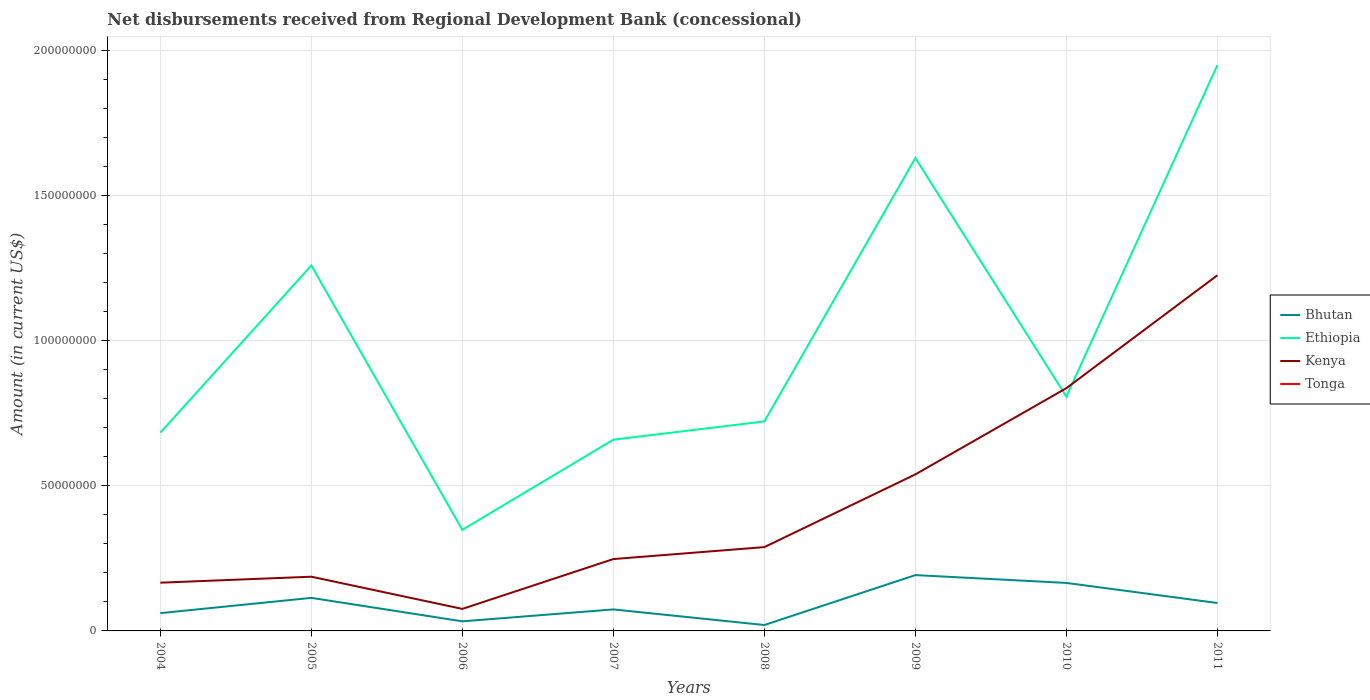Does the line corresponding to Kenya intersect with the line corresponding to Bhutan?
Your answer should be compact. No. Across all years, what is the maximum amount of disbursements received from Regional Development Bank in Ethiopia?
Ensure brevity in your answer.  3.48e+07. What is the total amount of disbursements received from Regional Development Bank in Bhutan in the graph?
Provide a succinct answer. -9.14e+06. What is the difference between the highest and the second highest amount of disbursements received from Regional Development Bank in Ethiopia?
Provide a short and direct response. 1.60e+08. What is the difference between the highest and the lowest amount of disbursements received from Regional Development Bank in Tonga?
Your answer should be compact. 0. How many lines are there?
Make the answer very short. 3. How many years are there in the graph?
Offer a terse response. 8. What is the difference between two consecutive major ticks on the Y-axis?
Ensure brevity in your answer.  5.00e+07. Are the values on the major ticks of Y-axis written in scientific E-notation?
Provide a succinct answer. No. Does the graph contain any zero values?
Provide a succinct answer. Yes. Where does the legend appear in the graph?
Offer a terse response. Center right. What is the title of the graph?
Offer a very short reply. Net disbursements received from Regional Development Bank (concessional). Does "Lesotho" appear as one of the legend labels in the graph?
Your answer should be compact. No. What is the Amount (in current US$) of Bhutan in 2004?
Provide a short and direct response. 6.13e+06. What is the Amount (in current US$) of Ethiopia in 2004?
Ensure brevity in your answer.  6.83e+07. What is the Amount (in current US$) of Kenya in 2004?
Give a very brief answer. 1.66e+07. What is the Amount (in current US$) of Bhutan in 2005?
Provide a succinct answer. 1.14e+07. What is the Amount (in current US$) in Ethiopia in 2005?
Offer a very short reply. 1.26e+08. What is the Amount (in current US$) in Kenya in 2005?
Ensure brevity in your answer.  1.87e+07. What is the Amount (in current US$) in Tonga in 2005?
Make the answer very short. 0. What is the Amount (in current US$) of Bhutan in 2006?
Keep it short and to the point. 3.30e+06. What is the Amount (in current US$) of Ethiopia in 2006?
Provide a short and direct response. 3.48e+07. What is the Amount (in current US$) in Kenya in 2006?
Offer a very short reply. 7.59e+06. What is the Amount (in current US$) of Bhutan in 2007?
Your answer should be compact. 7.41e+06. What is the Amount (in current US$) of Ethiopia in 2007?
Ensure brevity in your answer.  6.59e+07. What is the Amount (in current US$) of Kenya in 2007?
Offer a terse response. 2.48e+07. What is the Amount (in current US$) of Bhutan in 2008?
Offer a very short reply. 2.03e+06. What is the Amount (in current US$) of Ethiopia in 2008?
Keep it short and to the point. 7.22e+07. What is the Amount (in current US$) in Kenya in 2008?
Offer a very short reply. 2.89e+07. What is the Amount (in current US$) in Bhutan in 2009?
Your response must be concise. 1.92e+07. What is the Amount (in current US$) of Ethiopia in 2009?
Offer a very short reply. 1.63e+08. What is the Amount (in current US$) of Kenya in 2009?
Your answer should be very brief. 5.40e+07. What is the Amount (in current US$) in Tonga in 2009?
Offer a terse response. 0. What is the Amount (in current US$) in Bhutan in 2010?
Your answer should be very brief. 1.65e+07. What is the Amount (in current US$) in Ethiopia in 2010?
Offer a very short reply. 8.08e+07. What is the Amount (in current US$) of Kenya in 2010?
Offer a terse response. 8.37e+07. What is the Amount (in current US$) of Bhutan in 2011?
Provide a short and direct response. 9.62e+06. What is the Amount (in current US$) of Ethiopia in 2011?
Your answer should be very brief. 1.95e+08. What is the Amount (in current US$) in Kenya in 2011?
Keep it short and to the point. 1.23e+08. Across all years, what is the maximum Amount (in current US$) in Bhutan?
Provide a short and direct response. 1.92e+07. Across all years, what is the maximum Amount (in current US$) of Ethiopia?
Offer a very short reply. 1.95e+08. Across all years, what is the maximum Amount (in current US$) in Kenya?
Offer a terse response. 1.23e+08. Across all years, what is the minimum Amount (in current US$) in Bhutan?
Your answer should be compact. 2.03e+06. Across all years, what is the minimum Amount (in current US$) of Ethiopia?
Provide a succinct answer. 3.48e+07. Across all years, what is the minimum Amount (in current US$) in Kenya?
Provide a short and direct response. 7.59e+06. What is the total Amount (in current US$) of Bhutan in the graph?
Keep it short and to the point. 7.57e+07. What is the total Amount (in current US$) of Ethiopia in the graph?
Offer a very short reply. 8.06e+08. What is the total Amount (in current US$) in Kenya in the graph?
Keep it short and to the point. 3.57e+08. What is the difference between the Amount (in current US$) in Bhutan in 2004 and that in 2005?
Make the answer very short. -5.26e+06. What is the difference between the Amount (in current US$) in Ethiopia in 2004 and that in 2005?
Your response must be concise. -5.76e+07. What is the difference between the Amount (in current US$) of Kenya in 2004 and that in 2005?
Ensure brevity in your answer.  -2.06e+06. What is the difference between the Amount (in current US$) of Bhutan in 2004 and that in 2006?
Your response must be concise. 2.83e+06. What is the difference between the Amount (in current US$) of Ethiopia in 2004 and that in 2006?
Provide a short and direct response. 3.35e+07. What is the difference between the Amount (in current US$) of Kenya in 2004 and that in 2006?
Give a very brief answer. 9.04e+06. What is the difference between the Amount (in current US$) in Bhutan in 2004 and that in 2007?
Offer a terse response. -1.28e+06. What is the difference between the Amount (in current US$) in Ethiopia in 2004 and that in 2007?
Offer a terse response. 2.41e+06. What is the difference between the Amount (in current US$) in Kenya in 2004 and that in 2007?
Ensure brevity in your answer.  -8.14e+06. What is the difference between the Amount (in current US$) of Bhutan in 2004 and that in 2008?
Your response must be concise. 4.10e+06. What is the difference between the Amount (in current US$) in Ethiopia in 2004 and that in 2008?
Your answer should be very brief. -3.87e+06. What is the difference between the Amount (in current US$) in Kenya in 2004 and that in 2008?
Your answer should be compact. -1.23e+07. What is the difference between the Amount (in current US$) in Bhutan in 2004 and that in 2009?
Your response must be concise. -1.31e+07. What is the difference between the Amount (in current US$) in Ethiopia in 2004 and that in 2009?
Keep it short and to the point. -9.47e+07. What is the difference between the Amount (in current US$) of Kenya in 2004 and that in 2009?
Offer a very short reply. -3.73e+07. What is the difference between the Amount (in current US$) in Bhutan in 2004 and that in 2010?
Provide a short and direct response. -1.04e+07. What is the difference between the Amount (in current US$) of Ethiopia in 2004 and that in 2010?
Make the answer very short. -1.24e+07. What is the difference between the Amount (in current US$) of Kenya in 2004 and that in 2010?
Your answer should be very brief. -6.70e+07. What is the difference between the Amount (in current US$) in Bhutan in 2004 and that in 2011?
Give a very brief answer. -3.49e+06. What is the difference between the Amount (in current US$) in Ethiopia in 2004 and that in 2011?
Offer a very short reply. -1.27e+08. What is the difference between the Amount (in current US$) of Kenya in 2004 and that in 2011?
Provide a short and direct response. -1.06e+08. What is the difference between the Amount (in current US$) in Bhutan in 2005 and that in 2006?
Provide a short and direct response. 8.09e+06. What is the difference between the Amount (in current US$) in Ethiopia in 2005 and that in 2006?
Offer a very short reply. 9.11e+07. What is the difference between the Amount (in current US$) of Kenya in 2005 and that in 2006?
Make the answer very short. 1.11e+07. What is the difference between the Amount (in current US$) of Bhutan in 2005 and that in 2007?
Ensure brevity in your answer.  3.98e+06. What is the difference between the Amount (in current US$) of Ethiopia in 2005 and that in 2007?
Keep it short and to the point. 6.00e+07. What is the difference between the Amount (in current US$) in Kenya in 2005 and that in 2007?
Give a very brief answer. -6.08e+06. What is the difference between the Amount (in current US$) in Bhutan in 2005 and that in 2008?
Give a very brief answer. 9.36e+06. What is the difference between the Amount (in current US$) in Ethiopia in 2005 and that in 2008?
Make the answer very short. 5.37e+07. What is the difference between the Amount (in current US$) in Kenya in 2005 and that in 2008?
Offer a very short reply. -1.02e+07. What is the difference between the Amount (in current US$) of Bhutan in 2005 and that in 2009?
Provide a short and direct response. -7.85e+06. What is the difference between the Amount (in current US$) of Ethiopia in 2005 and that in 2009?
Provide a short and direct response. -3.70e+07. What is the difference between the Amount (in current US$) in Kenya in 2005 and that in 2009?
Offer a very short reply. -3.53e+07. What is the difference between the Amount (in current US$) in Bhutan in 2005 and that in 2010?
Your answer should be compact. -5.15e+06. What is the difference between the Amount (in current US$) of Ethiopia in 2005 and that in 2010?
Your answer should be compact. 4.52e+07. What is the difference between the Amount (in current US$) of Kenya in 2005 and that in 2010?
Offer a terse response. -6.50e+07. What is the difference between the Amount (in current US$) of Bhutan in 2005 and that in 2011?
Your response must be concise. 1.77e+06. What is the difference between the Amount (in current US$) in Ethiopia in 2005 and that in 2011?
Your response must be concise. -6.90e+07. What is the difference between the Amount (in current US$) in Kenya in 2005 and that in 2011?
Offer a terse response. -1.04e+08. What is the difference between the Amount (in current US$) in Bhutan in 2006 and that in 2007?
Make the answer very short. -4.10e+06. What is the difference between the Amount (in current US$) of Ethiopia in 2006 and that in 2007?
Your answer should be compact. -3.11e+07. What is the difference between the Amount (in current US$) of Kenya in 2006 and that in 2007?
Provide a short and direct response. -1.72e+07. What is the difference between the Amount (in current US$) of Bhutan in 2006 and that in 2008?
Offer a very short reply. 1.27e+06. What is the difference between the Amount (in current US$) in Ethiopia in 2006 and that in 2008?
Make the answer very short. -3.74e+07. What is the difference between the Amount (in current US$) in Kenya in 2006 and that in 2008?
Offer a terse response. -2.13e+07. What is the difference between the Amount (in current US$) of Bhutan in 2006 and that in 2009?
Make the answer very short. -1.59e+07. What is the difference between the Amount (in current US$) of Ethiopia in 2006 and that in 2009?
Your response must be concise. -1.28e+08. What is the difference between the Amount (in current US$) of Kenya in 2006 and that in 2009?
Provide a succinct answer. -4.64e+07. What is the difference between the Amount (in current US$) in Bhutan in 2006 and that in 2010?
Give a very brief answer. -1.32e+07. What is the difference between the Amount (in current US$) in Ethiopia in 2006 and that in 2010?
Offer a very short reply. -4.59e+07. What is the difference between the Amount (in current US$) in Kenya in 2006 and that in 2010?
Give a very brief answer. -7.61e+07. What is the difference between the Amount (in current US$) in Bhutan in 2006 and that in 2011?
Provide a short and direct response. -6.32e+06. What is the difference between the Amount (in current US$) in Ethiopia in 2006 and that in 2011?
Keep it short and to the point. -1.60e+08. What is the difference between the Amount (in current US$) of Kenya in 2006 and that in 2011?
Make the answer very short. -1.15e+08. What is the difference between the Amount (in current US$) in Bhutan in 2007 and that in 2008?
Your response must be concise. 5.38e+06. What is the difference between the Amount (in current US$) of Ethiopia in 2007 and that in 2008?
Your answer should be compact. -6.29e+06. What is the difference between the Amount (in current US$) of Kenya in 2007 and that in 2008?
Ensure brevity in your answer.  -4.12e+06. What is the difference between the Amount (in current US$) in Bhutan in 2007 and that in 2009?
Keep it short and to the point. -1.18e+07. What is the difference between the Amount (in current US$) in Ethiopia in 2007 and that in 2009?
Keep it short and to the point. -9.71e+07. What is the difference between the Amount (in current US$) of Kenya in 2007 and that in 2009?
Provide a short and direct response. -2.92e+07. What is the difference between the Amount (in current US$) in Bhutan in 2007 and that in 2010?
Your answer should be compact. -9.14e+06. What is the difference between the Amount (in current US$) of Ethiopia in 2007 and that in 2010?
Make the answer very short. -1.48e+07. What is the difference between the Amount (in current US$) of Kenya in 2007 and that in 2010?
Ensure brevity in your answer.  -5.89e+07. What is the difference between the Amount (in current US$) of Bhutan in 2007 and that in 2011?
Provide a short and direct response. -2.21e+06. What is the difference between the Amount (in current US$) of Ethiopia in 2007 and that in 2011?
Your response must be concise. -1.29e+08. What is the difference between the Amount (in current US$) of Kenya in 2007 and that in 2011?
Your answer should be compact. -9.78e+07. What is the difference between the Amount (in current US$) of Bhutan in 2008 and that in 2009?
Make the answer very short. -1.72e+07. What is the difference between the Amount (in current US$) of Ethiopia in 2008 and that in 2009?
Offer a terse response. -9.08e+07. What is the difference between the Amount (in current US$) in Kenya in 2008 and that in 2009?
Offer a very short reply. -2.51e+07. What is the difference between the Amount (in current US$) of Bhutan in 2008 and that in 2010?
Your answer should be compact. -1.45e+07. What is the difference between the Amount (in current US$) of Ethiopia in 2008 and that in 2010?
Ensure brevity in your answer.  -8.55e+06. What is the difference between the Amount (in current US$) of Kenya in 2008 and that in 2010?
Your answer should be compact. -5.48e+07. What is the difference between the Amount (in current US$) of Bhutan in 2008 and that in 2011?
Offer a terse response. -7.59e+06. What is the difference between the Amount (in current US$) in Ethiopia in 2008 and that in 2011?
Give a very brief answer. -1.23e+08. What is the difference between the Amount (in current US$) in Kenya in 2008 and that in 2011?
Your answer should be very brief. -9.37e+07. What is the difference between the Amount (in current US$) of Bhutan in 2009 and that in 2010?
Keep it short and to the point. 2.69e+06. What is the difference between the Amount (in current US$) of Ethiopia in 2009 and that in 2010?
Provide a short and direct response. 8.22e+07. What is the difference between the Amount (in current US$) of Kenya in 2009 and that in 2010?
Your answer should be compact. -2.97e+07. What is the difference between the Amount (in current US$) of Bhutan in 2009 and that in 2011?
Your response must be concise. 9.62e+06. What is the difference between the Amount (in current US$) of Ethiopia in 2009 and that in 2011?
Provide a short and direct response. -3.20e+07. What is the difference between the Amount (in current US$) of Kenya in 2009 and that in 2011?
Offer a very short reply. -6.86e+07. What is the difference between the Amount (in current US$) of Bhutan in 2010 and that in 2011?
Ensure brevity in your answer.  6.92e+06. What is the difference between the Amount (in current US$) in Ethiopia in 2010 and that in 2011?
Offer a very short reply. -1.14e+08. What is the difference between the Amount (in current US$) of Kenya in 2010 and that in 2011?
Give a very brief answer. -3.89e+07. What is the difference between the Amount (in current US$) in Bhutan in 2004 and the Amount (in current US$) in Ethiopia in 2005?
Your answer should be compact. -1.20e+08. What is the difference between the Amount (in current US$) of Bhutan in 2004 and the Amount (in current US$) of Kenya in 2005?
Your answer should be compact. -1.26e+07. What is the difference between the Amount (in current US$) of Ethiopia in 2004 and the Amount (in current US$) of Kenya in 2005?
Keep it short and to the point. 4.96e+07. What is the difference between the Amount (in current US$) in Bhutan in 2004 and the Amount (in current US$) in Ethiopia in 2006?
Make the answer very short. -2.87e+07. What is the difference between the Amount (in current US$) of Bhutan in 2004 and the Amount (in current US$) of Kenya in 2006?
Your answer should be very brief. -1.46e+06. What is the difference between the Amount (in current US$) in Ethiopia in 2004 and the Amount (in current US$) in Kenya in 2006?
Make the answer very short. 6.07e+07. What is the difference between the Amount (in current US$) of Bhutan in 2004 and the Amount (in current US$) of Ethiopia in 2007?
Provide a succinct answer. -5.98e+07. What is the difference between the Amount (in current US$) in Bhutan in 2004 and the Amount (in current US$) in Kenya in 2007?
Provide a succinct answer. -1.86e+07. What is the difference between the Amount (in current US$) of Ethiopia in 2004 and the Amount (in current US$) of Kenya in 2007?
Your answer should be compact. 4.36e+07. What is the difference between the Amount (in current US$) in Bhutan in 2004 and the Amount (in current US$) in Ethiopia in 2008?
Provide a succinct answer. -6.61e+07. What is the difference between the Amount (in current US$) in Bhutan in 2004 and the Amount (in current US$) in Kenya in 2008?
Your answer should be very brief. -2.28e+07. What is the difference between the Amount (in current US$) in Ethiopia in 2004 and the Amount (in current US$) in Kenya in 2008?
Provide a short and direct response. 3.94e+07. What is the difference between the Amount (in current US$) in Bhutan in 2004 and the Amount (in current US$) in Ethiopia in 2009?
Provide a short and direct response. -1.57e+08. What is the difference between the Amount (in current US$) in Bhutan in 2004 and the Amount (in current US$) in Kenya in 2009?
Your answer should be compact. -4.78e+07. What is the difference between the Amount (in current US$) of Ethiopia in 2004 and the Amount (in current US$) of Kenya in 2009?
Keep it short and to the point. 1.44e+07. What is the difference between the Amount (in current US$) of Bhutan in 2004 and the Amount (in current US$) of Ethiopia in 2010?
Provide a short and direct response. -7.46e+07. What is the difference between the Amount (in current US$) in Bhutan in 2004 and the Amount (in current US$) in Kenya in 2010?
Give a very brief answer. -7.75e+07. What is the difference between the Amount (in current US$) of Ethiopia in 2004 and the Amount (in current US$) of Kenya in 2010?
Your answer should be very brief. -1.53e+07. What is the difference between the Amount (in current US$) of Bhutan in 2004 and the Amount (in current US$) of Ethiopia in 2011?
Your response must be concise. -1.89e+08. What is the difference between the Amount (in current US$) in Bhutan in 2004 and the Amount (in current US$) in Kenya in 2011?
Offer a terse response. -1.16e+08. What is the difference between the Amount (in current US$) of Ethiopia in 2004 and the Amount (in current US$) of Kenya in 2011?
Your answer should be compact. -5.42e+07. What is the difference between the Amount (in current US$) of Bhutan in 2005 and the Amount (in current US$) of Ethiopia in 2006?
Give a very brief answer. -2.34e+07. What is the difference between the Amount (in current US$) of Bhutan in 2005 and the Amount (in current US$) of Kenya in 2006?
Keep it short and to the point. 3.80e+06. What is the difference between the Amount (in current US$) of Ethiopia in 2005 and the Amount (in current US$) of Kenya in 2006?
Keep it short and to the point. 1.18e+08. What is the difference between the Amount (in current US$) of Bhutan in 2005 and the Amount (in current US$) of Ethiopia in 2007?
Your answer should be very brief. -5.45e+07. What is the difference between the Amount (in current US$) in Bhutan in 2005 and the Amount (in current US$) in Kenya in 2007?
Your response must be concise. -1.34e+07. What is the difference between the Amount (in current US$) of Ethiopia in 2005 and the Amount (in current US$) of Kenya in 2007?
Your answer should be very brief. 1.01e+08. What is the difference between the Amount (in current US$) of Bhutan in 2005 and the Amount (in current US$) of Ethiopia in 2008?
Your answer should be compact. -6.08e+07. What is the difference between the Amount (in current US$) of Bhutan in 2005 and the Amount (in current US$) of Kenya in 2008?
Your answer should be compact. -1.75e+07. What is the difference between the Amount (in current US$) of Ethiopia in 2005 and the Amount (in current US$) of Kenya in 2008?
Offer a very short reply. 9.71e+07. What is the difference between the Amount (in current US$) in Bhutan in 2005 and the Amount (in current US$) in Ethiopia in 2009?
Offer a terse response. -1.52e+08. What is the difference between the Amount (in current US$) of Bhutan in 2005 and the Amount (in current US$) of Kenya in 2009?
Keep it short and to the point. -4.26e+07. What is the difference between the Amount (in current US$) of Ethiopia in 2005 and the Amount (in current US$) of Kenya in 2009?
Your response must be concise. 7.20e+07. What is the difference between the Amount (in current US$) in Bhutan in 2005 and the Amount (in current US$) in Ethiopia in 2010?
Provide a short and direct response. -6.94e+07. What is the difference between the Amount (in current US$) in Bhutan in 2005 and the Amount (in current US$) in Kenya in 2010?
Your answer should be very brief. -7.23e+07. What is the difference between the Amount (in current US$) of Ethiopia in 2005 and the Amount (in current US$) of Kenya in 2010?
Offer a terse response. 4.23e+07. What is the difference between the Amount (in current US$) of Bhutan in 2005 and the Amount (in current US$) of Ethiopia in 2011?
Keep it short and to the point. -1.84e+08. What is the difference between the Amount (in current US$) of Bhutan in 2005 and the Amount (in current US$) of Kenya in 2011?
Offer a very short reply. -1.11e+08. What is the difference between the Amount (in current US$) in Ethiopia in 2005 and the Amount (in current US$) in Kenya in 2011?
Make the answer very short. 3.37e+06. What is the difference between the Amount (in current US$) in Bhutan in 2006 and the Amount (in current US$) in Ethiopia in 2007?
Your response must be concise. -6.26e+07. What is the difference between the Amount (in current US$) in Bhutan in 2006 and the Amount (in current US$) in Kenya in 2007?
Your answer should be compact. -2.15e+07. What is the difference between the Amount (in current US$) of Ethiopia in 2006 and the Amount (in current US$) of Kenya in 2007?
Provide a succinct answer. 1.01e+07. What is the difference between the Amount (in current US$) in Bhutan in 2006 and the Amount (in current US$) in Ethiopia in 2008?
Give a very brief answer. -6.89e+07. What is the difference between the Amount (in current US$) of Bhutan in 2006 and the Amount (in current US$) of Kenya in 2008?
Your answer should be compact. -2.56e+07. What is the difference between the Amount (in current US$) of Ethiopia in 2006 and the Amount (in current US$) of Kenya in 2008?
Make the answer very short. 5.94e+06. What is the difference between the Amount (in current US$) of Bhutan in 2006 and the Amount (in current US$) of Ethiopia in 2009?
Offer a very short reply. -1.60e+08. What is the difference between the Amount (in current US$) in Bhutan in 2006 and the Amount (in current US$) in Kenya in 2009?
Make the answer very short. -5.06e+07. What is the difference between the Amount (in current US$) in Ethiopia in 2006 and the Amount (in current US$) in Kenya in 2009?
Ensure brevity in your answer.  -1.91e+07. What is the difference between the Amount (in current US$) in Bhutan in 2006 and the Amount (in current US$) in Ethiopia in 2010?
Your answer should be very brief. -7.74e+07. What is the difference between the Amount (in current US$) of Bhutan in 2006 and the Amount (in current US$) of Kenya in 2010?
Your answer should be very brief. -8.04e+07. What is the difference between the Amount (in current US$) in Ethiopia in 2006 and the Amount (in current US$) in Kenya in 2010?
Keep it short and to the point. -4.88e+07. What is the difference between the Amount (in current US$) of Bhutan in 2006 and the Amount (in current US$) of Ethiopia in 2011?
Provide a short and direct response. -1.92e+08. What is the difference between the Amount (in current US$) of Bhutan in 2006 and the Amount (in current US$) of Kenya in 2011?
Offer a very short reply. -1.19e+08. What is the difference between the Amount (in current US$) of Ethiopia in 2006 and the Amount (in current US$) of Kenya in 2011?
Give a very brief answer. -8.77e+07. What is the difference between the Amount (in current US$) of Bhutan in 2007 and the Amount (in current US$) of Ethiopia in 2008?
Your response must be concise. -6.48e+07. What is the difference between the Amount (in current US$) in Bhutan in 2007 and the Amount (in current US$) in Kenya in 2008?
Ensure brevity in your answer.  -2.15e+07. What is the difference between the Amount (in current US$) of Ethiopia in 2007 and the Amount (in current US$) of Kenya in 2008?
Your response must be concise. 3.70e+07. What is the difference between the Amount (in current US$) of Bhutan in 2007 and the Amount (in current US$) of Ethiopia in 2009?
Provide a short and direct response. -1.56e+08. What is the difference between the Amount (in current US$) of Bhutan in 2007 and the Amount (in current US$) of Kenya in 2009?
Your answer should be compact. -4.65e+07. What is the difference between the Amount (in current US$) in Ethiopia in 2007 and the Amount (in current US$) in Kenya in 2009?
Make the answer very short. 1.20e+07. What is the difference between the Amount (in current US$) of Bhutan in 2007 and the Amount (in current US$) of Ethiopia in 2010?
Keep it short and to the point. -7.33e+07. What is the difference between the Amount (in current US$) in Bhutan in 2007 and the Amount (in current US$) in Kenya in 2010?
Give a very brief answer. -7.63e+07. What is the difference between the Amount (in current US$) in Ethiopia in 2007 and the Amount (in current US$) in Kenya in 2010?
Provide a short and direct response. -1.78e+07. What is the difference between the Amount (in current US$) of Bhutan in 2007 and the Amount (in current US$) of Ethiopia in 2011?
Provide a short and direct response. -1.88e+08. What is the difference between the Amount (in current US$) in Bhutan in 2007 and the Amount (in current US$) in Kenya in 2011?
Ensure brevity in your answer.  -1.15e+08. What is the difference between the Amount (in current US$) of Ethiopia in 2007 and the Amount (in current US$) of Kenya in 2011?
Offer a terse response. -5.67e+07. What is the difference between the Amount (in current US$) in Bhutan in 2008 and the Amount (in current US$) in Ethiopia in 2009?
Offer a very short reply. -1.61e+08. What is the difference between the Amount (in current US$) of Bhutan in 2008 and the Amount (in current US$) of Kenya in 2009?
Give a very brief answer. -5.19e+07. What is the difference between the Amount (in current US$) of Ethiopia in 2008 and the Amount (in current US$) of Kenya in 2009?
Provide a succinct answer. 1.82e+07. What is the difference between the Amount (in current US$) in Bhutan in 2008 and the Amount (in current US$) in Ethiopia in 2010?
Your response must be concise. -7.87e+07. What is the difference between the Amount (in current US$) in Bhutan in 2008 and the Amount (in current US$) in Kenya in 2010?
Provide a succinct answer. -8.16e+07. What is the difference between the Amount (in current US$) of Ethiopia in 2008 and the Amount (in current US$) of Kenya in 2010?
Your answer should be very brief. -1.15e+07. What is the difference between the Amount (in current US$) in Bhutan in 2008 and the Amount (in current US$) in Ethiopia in 2011?
Your answer should be very brief. -1.93e+08. What is the difference between the Amount (in current US$) of Bhutan in 2008 and the Amount (in current US$) of Kenya in 2011?
Provide a succinct answer. -1.21e+08. What is the difference between the Amount (in current US$) in Ethiopia in 2008 and the Amount (in current US$) in Kenya in 2011?
Give a very brief answer. -5.04e+07. What is the difference between the Amount (in current US$) of Bhutan in 2009 and the Amount (in current US$) of Ethiopia in 2010?
Offer a terse response. -6.15e+07. What is the difference between the Amount (in current US$) in Bhutan in 2009 and the Amount (in current US$) in Kenya in 2010?
Offer a very short reply. -6.44e+07. What is the difference between the Amount (in current US$) of Ethiopia in 2009 and the Amount (in current US$) of Kenya in 2010?
Provide a short and direct response. 7.93e+07. What is the difference between the Amount (in current US$) in Bhutan in 2009 and the Amount (in current US$) in Ethiopia in 2011?
Your response must be concise. -1.76e+08. What is the difference between the Amount (in current US$) of Bhutan in 2009 and the Amount (in current US$) of Kenya in 2011?
Your response must be concise. -1.03e+08. What is the difference between the Amount (in current US$) of Ethiopia in 2009 and the Amount (in current US$) of Kenya in 2011?
Offer a terse response. 4.04e+07. What is the difference between the Amount (in current US$) in Bhutan in 2010 and the Amount (in current US$) in Ethiopia in 2011?
Your answer should be compact. -1.78e+08. What is the difference between the Amount (in current US$) in Bhutan in 2010 and the Amount (in current US$) in Kenya in 2011?
Provide a succinct answer. -1.06e+08. What is the difference between the Amount (in current US$) in Ethiopia in 2010 and the Amount (in current US$) in Kenya in 2011?
Your answer should be compact. -4.18e+07. What is the average Amount (in current US$) in Bhutan per year?
Your answer should be very brief. 9.46e+06. What is the average Amount (in current US$) of Ethiopia per year?
Make the answer very short. 1.01e+08. What is the average Amount (in current US$) in Kenya per year?
Provide a succinct answer. 4.46e+07. What is the average Amount (in current US$) of Tonga per year?
Ensure brevity in your answer.  0. In the year 2004, what is the difference between the Amount (in current US$) in Bhutan and Amount (in current US$) in Ethiopia?
Provide a succinct answer. -6.22e+07. In the year 2004, what is the difference between the Amount (in current US$) of Bhutan and Amount (in current US$) of Kenya?
Ensure brevity in your answer.  -1.05e+07. In the year 2004, what is the difference between the Amount (in current US$) in Ethiopia and Amount (in current US$) in Kenya?
Make the answer very short. 5.17e+07. In the year 2005, what is the difference between the Amount (in current US$) of Bhutan and Amount (in current US$) of Ethiopia?
Make the answer very short. -1.15e+08. In the year 2005, what is the difference between the Amount (in current US$) in Bhutan and Amount (in current US$) in Kenya?
Make the answer very short. -7.29e+06. In the year 2005, what is the difference between the Amount (in current US$) in Ethiopia and Amount (in current US$) in Kenya?
Offer a terse response. 1.07e+08. In the year 2006, what is the difference between the Amount (in current US$) in Bhutan and Amount (in current US$) in Ethiopia?
Your answer should be very brief. -3.15e+07. In the year 2006, what is the difference between the Amount (in current US$) of Bhutan and Amount (in current US$) of Kenya?
Provide a succinct answer. -4.29e+06. In the year 2006, what is the difference between the Amount (in current US$) in Ethiopia and Amount (in current US$) in Kenya?
Your answer should be compact. 2.72e+07. In the year 2007, what is the difference between the Amount (in current US$) of Bhutan and Amount (in current US$) of Ethiopia?
Give a very brief answer. -5.85e+07. In the year 2007, what is the difference between the Amount (in current US$) of Bhutan and Amount (in current US$) of Kenya?
Keep it short and to the point. -1.74e+07. In the year 2007, what is the difference between the Amount (in current US$) in Ethiopia and Amount (in current US$) in Kenya?
Provide a succinct answer. 4.11e+07. In the year 2008, what is the difference between the Amount (in current US$) in Bhutan and Amount (in current US$) in Ethiopia?
Your response must be concise. -7.02e+07. In the year 2008, what is the difference between the Amount (in current US$) of Bhutan and Amount (in current US$) of Kenya?
Provide a short and direct response. -2.69e+07. In the year 2008, what is the difference between the Amount (in current US$) of Ethiopia and Amount (in current US$) of Kenya?
Give a very brief answer. 4.33e+07. In the year 2009, what is the difference between the Amount (in current US$) of Bhutan and Amount (in current US$) of Ethiopia?
Make the answer very short. -1.44e+08. In the year 2009, what is the difference between the Amount (in current US$) of Bhutan and Amount (in current US$) of Kenya?
Provide a short and direct response. -3.47e+07. In the year 2009, what is the difference between the Amount (in current US$) of Ethiopia and Amount (in current US$) of Kenya?
Offer a very short reply. 1.09e+08. In the year 2010, what is the difference between the Amount (in current US$) of Bhutan and Amount (in current US$) of Ethiopia?
Keep it short and to the point. -6.42e+07. In the year 2010, what is the difference between the Amount (in current US$) in Bhutan and Amount (in current US$) in Kenya?
Make the answer very short. -6.71e+07. In the year 2010, what is the difference between the Amount (in current US$) of Ethiopia and Amount (in current US$) of Kenya?
Provide a short and direct response. -2.92e+06. In the year 2011, what is the difference between the Amount (in current US$) of Bhutan and Amount (in current US$) of Ethiopia?
Make the answer very short. -1.85e+08. In the year 2011, what is the difference between the Amount (in current US$) of Bhutan and Amount (in current US$) of Kenya?
Make the answer very short. -1.13e+08. In the year 2011, what is the difference between the Amount (in current US$) in Ethiopia and Amount (in current US$) in Kenya?
Provide a short and direct response. 7.24e+07. What is the ratio of the Amount (in current US$) of Bhutan in 2004 to that in 2005?
Your response must be concise. 0.54. What is the ratio of the Amount (in current US$) in Ethiopia in 2004 to that in 2005?
Provide a succinct answer. 0.54. What is the ratio of the Amount (in current US$) of Kenya in 2004 to that in 2005?
Your answer should be very brief. 0.89. What is the ratio of the Amount (in current US$) of Bhutan in 2004 to that in 2006?
Provide a succinct answer. 1.86. What is the ratio of the Amount (in current US$) in Ethiopia in 2004 to that in 2006?
Ensure brevity in your answer.  1.96. What is the ratio of the Amount (in current US$) of Kenya in 2004 to that in 2006?
Your response must be concise. 2.19. What is the ratio of the Amount (in current US$) in Bhutan in 2004 to that in 2007?
Provide a short and direct response. 0.83. What is the ratio of the Amount (in current US$) of Ethiopia in 2004 to that in 2007?
Make the answer very short. 1.04. What is the ratio of the Amount (in current US$) in Kenya in 2004 to that in 2007?
Keep it short and to the point. 0.67. What is the ratio of the Amount (in current US$) of Bhutan in 2004 to that in 2008?
Your answer should be very brief. 3.02. What is the ratio of the Amount (in current US$) in Ethiopia in 2004 to that in 2008?
Make the answer very short. 0.95. What is the ratio of the Amount (in current US$) of Kenya in 2004 to that in 2008?
Provide a succinct answer. 0.58. What is the ratio of the Amount (in current US$) in Bhutan in 2004 to that in 2009?
Your response must be concise. 0.32. What is the ratio of the Amount (in current US$) of Ethiopia in 2004 to that in 2009?
Give a very brief answer. 0.42. What is the ratio of the Amount (in current US$) of Kenya in 2004 to that in 2009?
Offer a terse response. 0.31. What is the ratio of the Amount (in current US$) of Bhutan in 2004 to that in 2010?
Offer a terse response. 0.37. What is the ratio of the Amount (in current US$) in Ethiopia in 2004 to that in 2010?
Keep it short and to the point. 0.85. What is the ratio of the Amount (in current US$) of Kenya in 2004 to that in 2010?
Provide a succinct answer. 0.2. What is the ratio of the Amount (in current US$) of Bhutan in 2004 to that in 2011?
Your answer should be very brief. 0.64. What is the ratio of the Amount (in current US$) in Ethiopia in 2004 to that in 2011?
Ensure brevity in your answer.  0.35. What is the ratio of the Amount (in current US$) in Kenya in 2004 to that in 2011?
Your answer should be compact. 0.14. What is the ratio of the Amount (in current US$) of Bhutan in 2005 to that in 2006?
Provide a succinct answer. 3.45. What is the ratio of the Amount (in current US$) in Ethiopia in 2005 to that in 2006?
Give a very brief answer. 3.62. What is the ratio of the Amount (in current US$) in Kenya in 2005 to that in 2006?
Your response must be concise. 2.46. What is the ratio of the Amount (in current US$) in Bhutan in 2005 to that in 2007?
Your answer should be very brief. 1.54. What is the ratio of the Amount (in current US$) of Ethiopia in 2005 to that in 2007?
Give a very brief answer. 1.91. What is the ratio of the Amount (in current US$) of Kenya in 2005 to that in 2007?
Your answer should be very brief. 0.75. What is the ratio of the Amount (in current US$) in Bhutan in 2005 to that in 2008?
Provide a succinct answer. 5.6. What is the ratio of the Amount (in current US$) in Ethiopia in 2005 to that in 2008?
Give a very brief answer. 1.74. What is the ratio of the Amount (in current US$) of Kenya in 2005 to that in 2008?
Your response must be concise. 0.65. What is the ratio of the Amount (in current US$) of Bhutan in 2005 to that in 2009?
Your answer should be very brief. 0.59. What is the ratio of the Amount (in current US$) of Ethiopia in 2005 to that in 2009?
Keep it short and to the point. 0.77. What is the ratio of the Amount (in current US$) of Kenya in 2005 to that in 2009?
Ensure brevity in your answer.  0.35. What is the ratio of the Amount (in current US$) of Bhutan in 2005 to that in 2010?
Your answer should be very brief. 0.69. What is the ratio of the Amount (in current US$) in Ethiopia in 2005 to that in 2010?
Offer a very short reply. 1.56. What is the ratio of the Amount (in current US$) of Kenya in 2005 to that in 2010?
Make the answer very short. 0.22. What is the ratio of the Amount (in current US$) in Bhutan in 2005 to that in 2011?
Make the answer very short. 1.18. What is the ratio of the Amount (in current US$) in Ethiopia in 2005 to that in 2011?
Ensure brevity in your answer.  0.65. What is the ratio of the Amount (in current US$) of Kenya in 2005 to that in 2011?
Keep it short and to the point. 0.15. What is the ratio of the Amount (in current US$) of Bhutan in 2006 to that in 2007?
Ensure brevity in your answer.  0.45. What is the ratio of the Amount (in current US$) in Ethiopia in 2006 to that in 2007?
Provide a short and direct response. 0.53. What is the ratio of the Amount (in current US$) of Kenya in 2006 to that in 2007?
Your answer should be compact. 0.31. What is the ratio of the Amount (in current US$) of Bhutan in 2006 to that in 2008?
Provide a short and direct response. 1.63. What is the ratio of the Amount (in current US$) in Ethiopia in 2006 to that in 2008?
Provide a succinct answer. 0.48. What is the ratio of the Amount (in current US$) in Kenya in 2006 to that in 2008?
Your answer should be very brief. 0.26. What is the ratio of the Amount (in current US$) of Bhutan in 2006 to that in 2009?
Provide a short and direct response. 0.17. What is the ratio of the Amount (in current US$) in Ethiopia in 2006 to that in 2009?
Your answer should be compact. 0.21. What is the ratio of the Amount (in current US$) in Kenya in 2006 to that in 2009?
Offer a very short reply. 0.14. What is the ratio of the Amount (in current US$) in Bhutan in 2006 to that in 2010?
Keep it short and to the point. 0.2. What is the ratio of the Amount (in current US$) of Ethiopia in 2006 to that in 2010?
Make the answer very short. 0.43. What is the ratio of the Amount (in current US$) in Kenya in 2006 to that in 2010?
Ensure brevity in your answer.  0.09. What is the ratio of the Amount (in current US$) of Bhutan in 2006 to that in 2011?
Your response must be concise. 0.34. What is the ratio of the Amount (in current US$) of Ethiopia in 2006 to that in 2011?
Ensure brevity in your answer.  0.18. What is the ratio of the Amount (in current US$) of Kenya in 2006 to that in 2011?
Keep it short and to the point. 0.06. What is the ratio of the Amount (in current US$) in Bhutan in 2007 to that in 2008?
Your response must be concise. 3.64. What is the ratio of the Amount (in current US$) in Ethiopia in 2007 to that in 2008?
Your answer should be very brief. 0.91. What is the ratio of the Amount (in current US$) of Kenya in 2007 to that in 2008?
Your answer should be compact. 0.86. What is the ratio of the Amount (in current US$) in Bhutan in 2007 to that in 2009?
Keep it short and to the point. 0.39. What is the ratio of the Amount (in current US$) in Ethiopia in 2007 to that in 2009?
Make the answer very short. 0.4. What is the ratio of the Amount (in current US$) of Kenya in 2007 to that in 2009?
Ensure brevity in your answer.  0.46. What is the ratio of the Amount (in current US$) of Bhutan in 2007 to that in 2010?
Your answer should be compact. 0.45. What is the ratio of the Amount (in current US$) of Ethiopia in 2007 to that in 2010?
Give a very brief answer. 0.82. What is the ratio of the Amount (in current US$) of Kenya in 2007 to that in 2010?
Keep it short and to the point. 0.3. What is the ratio of the Amount (in current US$) in Bhutan in 2007 to that in 2011?
Your response must be concise. 0.77. What is the ratio of the Amount (in current US$) of Ethiopia in 2007 to that in 2011?
Make the answer very short. 0.34. What is the ratio of the Amount (in current US$) in Kenya in 2007 to that in 2011?
Offer a terse response. 0.2. What is the ratio of the Amount (in current US$) in Bhutan in 2008 to that in 2009?
Offer a terse response. 0.11. What is the ratio of the Amount (in current US$) in Ethiopia in 2008 to that in 2009?
Offer a very short reply. 0.44. What is the ratio of the Amount (in current US$) of Kenya in 2008 to that in 2009?
Provide a short and direct response. 0.54. What is the ratio of the Amount (in current US$) of Bhutan in 2008 to that in 2010?
Give a very brief answer. 0.12. What is the ratio of the Amount (in current US$) in Ethiopia in 2008 to that in 2010?
Offer a very short reply. 0.89. What is the ratio of the Amount (in current US$) in Kenya in 2008 to that in 2010?
Ensure brevity in your answer.  0.35. What is the ratio of the Amount (in current US$) in Bhutan in 2008 to that in 2011?
Give a very brief answer. 0.21. What is the ratio of the Amount (in current US$) in Ethiopia in 2008 to that in 2011?
Your response must be concise. 0.37. What is the ratio of the Amount (in current US$) in Kenya in 2008 to that in 2011?
Keep it short and to the point. 0.24. What is the ratio of the Amount (in current US$) in Bhutan in 2009 to that in 2010?
Your answer should be compact. 1.16. What is the ratio of the Amount (in current US$) of Ethiopia in 2009 to that in 2010?
Give a very brief answer. 2.02. What is the ratio of the Amount (in current US$) of Kenya in 2009 to that in 2010?
Offer a terse response. 0.64. What is the ratio of the Amount (in current US$) in Ethiopia in 2009 to that in 2011?
Your response must be concise. 0.84. What is the ratio of the Amount (in current US$) of Kenya in 2009 to that in 2011?
Give a very brief answer. 0.44. What is the ratio of the Amount (in current US$) in Bhutan in 2010 to that in 2011?
Offer a terse response. 1.72. What is the ratio of the Amount (in current US$) of Ethiopia in 2010 to that in 2011?
Your answer should be very brief. 0.41. What is the ratio of the Amount (in current US$) in Kenya in 2010 to that in 2011?
Make the answer very short. 0.68. What is the difference between the highest and the second highest Amount (in current US$) of Bhutan?
Make the answer very short. 2.69e+06. What is the difference between the highest and the second highest Amount (in current US$) of Ethiopia?
Your response must be concise. 3.20e+07. What is the difference between the highest and the second highest Amount (in current US$) in Kenya?
Offer a very short reply. 3.89e+07. What is the difference between the highest and the lowest Amount (in current US$) in Bhutan?
Your answer should be very brief. 1.72e+07. What is the difference between the highest and the lowest Amount (in current US$) in Ethiopia?
Give a very brief answer. 1.60e+08. What is the difference between the highest and the lowest Amount (in current US$) of Kenya?
Offer a terse response. 1.15e+08. 